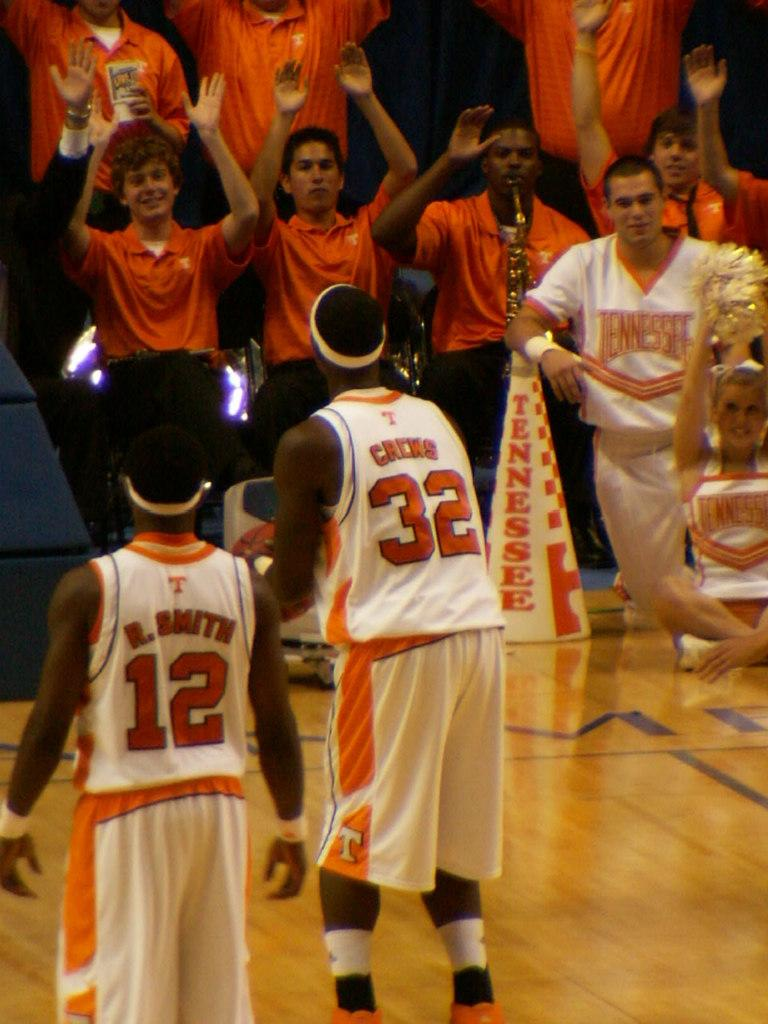<image>
Summarize the visual content of the image. Tennesse basketball players being cheered on by the band members 